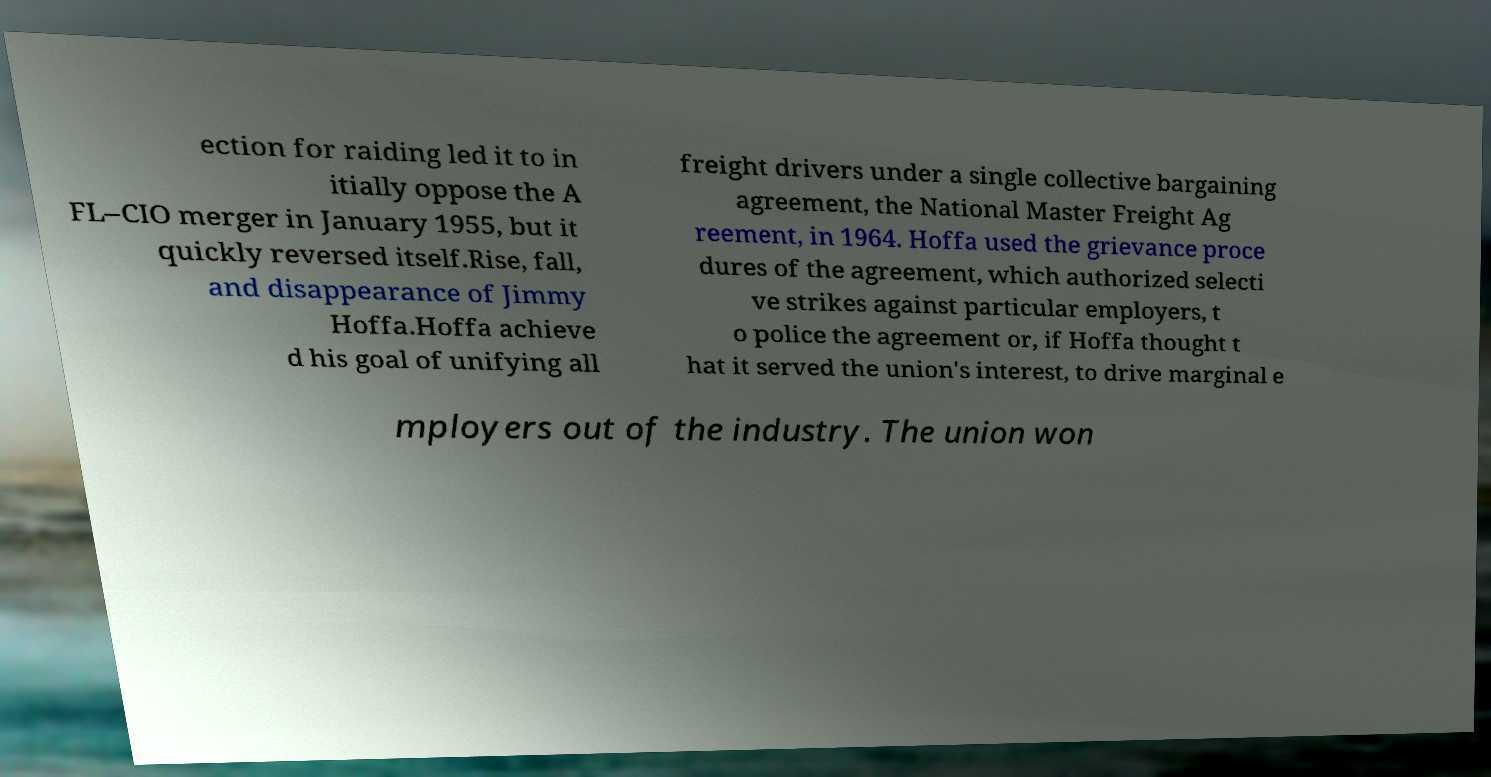Can you accurately transcribe the text from the provided image for me? ection for raiding led it to in itially oppose the A FL–CIO merger in January 1955, but it quickly reversed itself.Rise, fall, and disappearance of Jimmy Hoffa.Hoffa achieve d his goal of unifying all freight drivers under a single collective bargaining agreement, the National Master Freight Ag reement, in 1964. Hoffa used the grievance proce dures of the agreement, which authorized selecti ve strikes against particular employers, t o police the agreement or, if Hoffa thought t hat it served the union's interest, to drive marginal e mployers out of the industry. The union won 